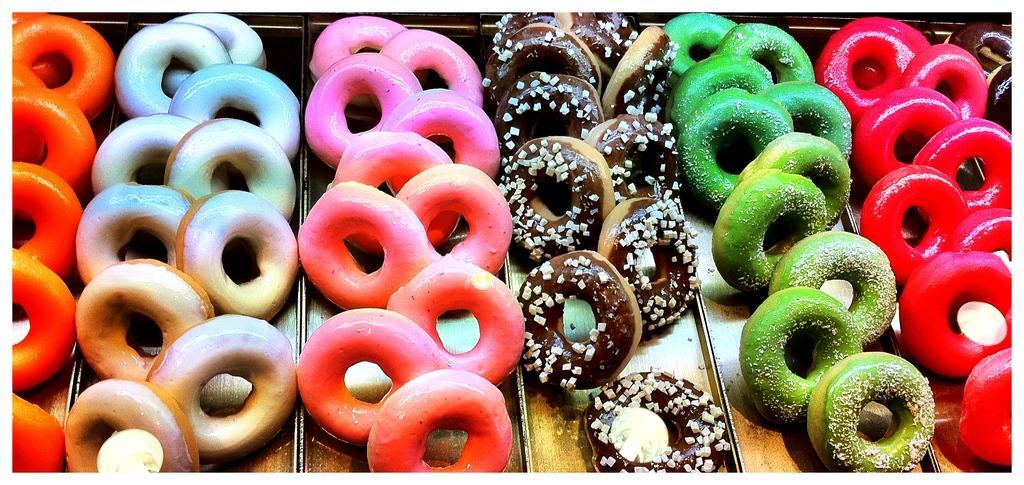Can you describe this image briefly? In this image we can see different colors of doughnut in separate plates. 